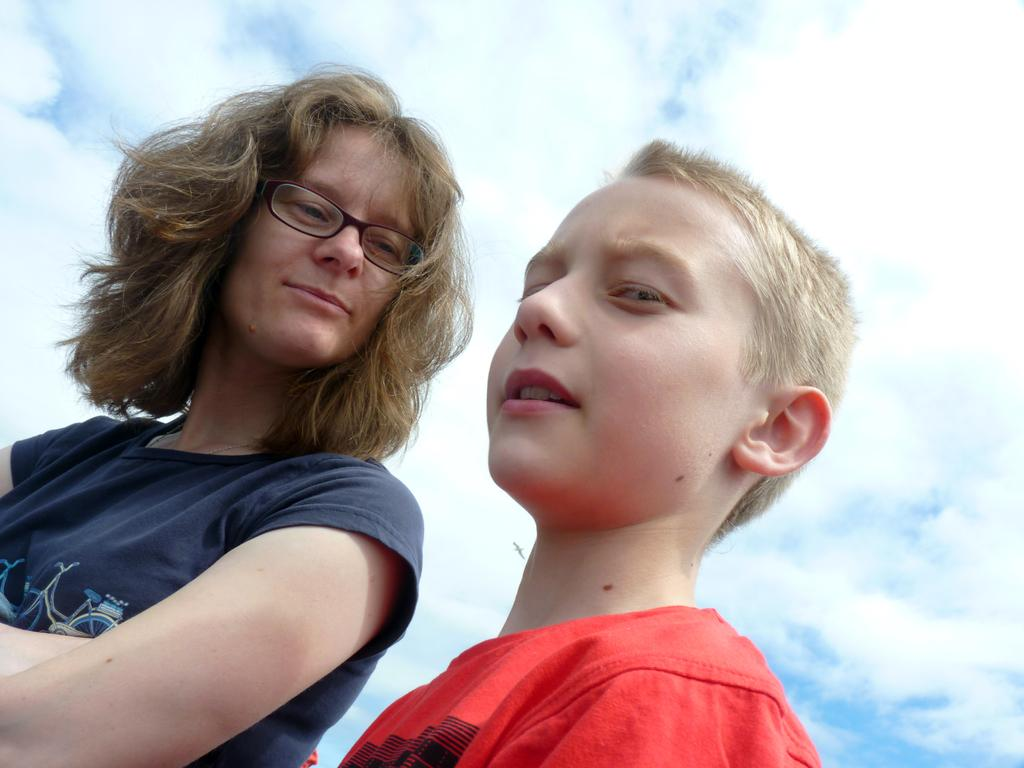Where was the image taken? The image was clicked outside. How many people are in the foreground of the image? There are two people in the foreground of the image. What are the people wearing? The people are wearing t-shirts. What is the position of the people in the image? The people appear to be standing. What can be seen in the background of the image? There is a sky visible in the background of the image. What is the weather like in the image? The presence of clouds in the sky suggests that it might be partly cloudy. What type of haircut does the governor have in the image? There is no governor present in the image, and therefore no haircut can be observed. What material is the lead used for in the image? There is no lead present in the image, so it is not possible to determine what material it might be made of or what it might be used for. 